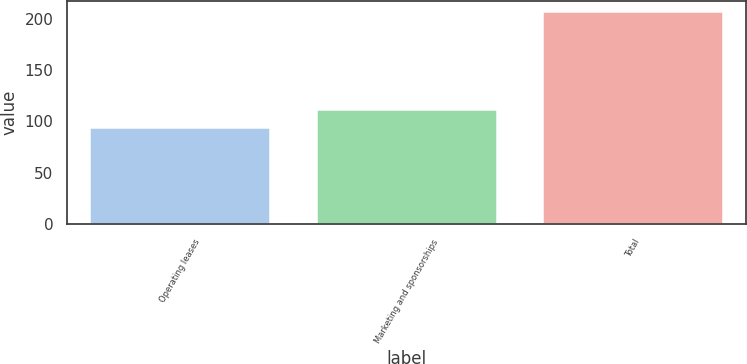<chart> <loc_0><loc_0><loc_500><loc_500><bar_chart><fcel>Operating leases<fcel>Marketing and sponsorships<fcel>Total<nl><fcel>95<fcel>112<fcel>207<nl></chart> 